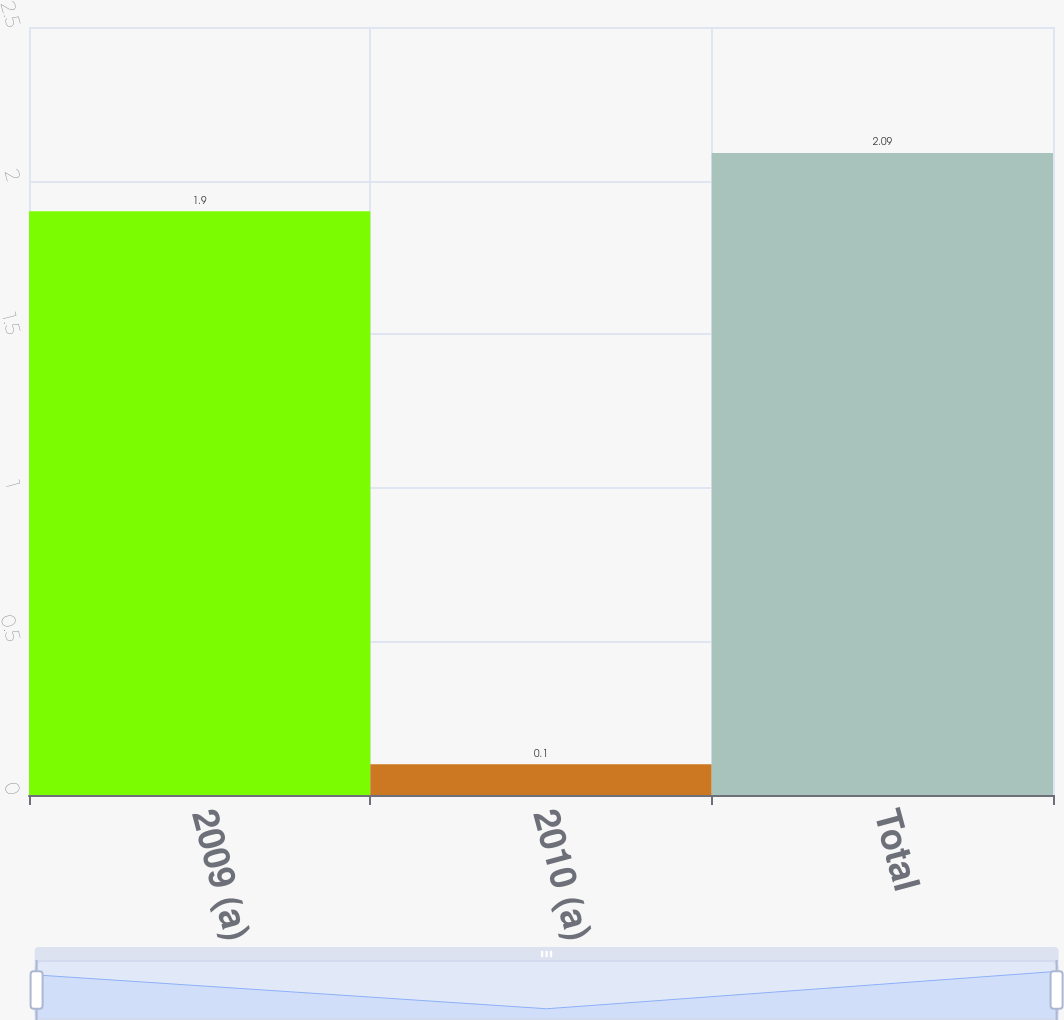Convert chart to OTSL. <chart><loc_0><loc_0><loc_500><loc_500><bar_chart><fcel>2009 (a)<fcel>2010 (a)<fcel>Total<nl><fcel>1.9<fcel>0.1<fcel>2.09<nl></chart> 